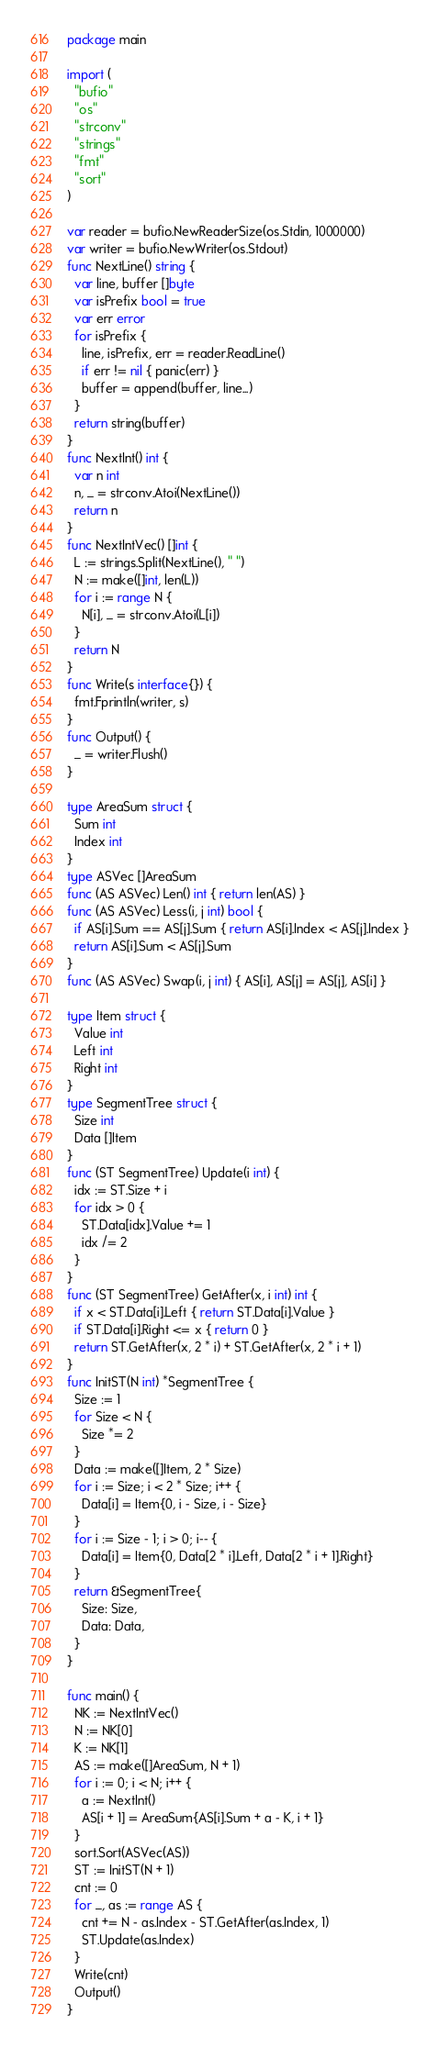<code> <loc_0><loc_0><loc_500><loc_500><_Go_>package main
 
import (
  "bufio"
  "os"
  "strconv"
  "strings"
  "fmt"
  "sort"
)
 
var reader = bufio.NewReaderSize(os.Stdin, 1000000)
var writer = bufio.NewWriter(os.Stdout)
func NextLine() string {
  var line, buffer []byte
  var isPrefix bool = true
  var err error
  for isPrefix {
    line, isPrefix, err = reader.ReadLine()
    if err != nil { panic(err) }
    buffer = append(buffer, line...)
  }
  return string(buffer)
}
func NextInt() int {
  var n int
  n, _ = strconv.Atoi(NextLine())
  return n
}
func NextIntVec() []int {
  L := strings.Split(NextLine(), " ")
  N := make([]int, len(L))
  for i := range N {
    N[i], _ = strconv.Atoi(L[i])
  }
  return N
}
func Write(s interface{}) {
  fmt.Fprintln(writer, s)
}
func Output() {
  _ = writer.Flush()
}

type AreaSum struct {
  Sum int
  Index int
}
type ASVec []AreaSum
func (AS ASVec) Len() int { return len(AS) }
func (AS ASVec) Less(i, j int) bool {
  if AS[i].Sum == AS[j].Sum { return AS[i].Index < AS[j].Index }
  return AS[i].Sum < AS[j].Sum
}
func (AS ASVec) Swap(i, j int) { AS[i], AS[j] = AS[j], AS[i] }

type Item struct {
  Value int
  Left int
  Right int
}
type SegmentTree struct {
  Size int
  Data []Item
}
func (ST SegmentTree) Update(i int) {
  idx := ST.Size + i
  for idx > 0 {
    ST.Data[idx].Value += 1
    idx /= 2
  }
}
func (ST SegmentTree) GetAfter(x, i int) int {
  if x < ST.Data[i].Left { return ST.Data[i].Value }
  if ST.Data[i].Right <= x { return 0 }
  return ST.GetAfter(x, 2 * i) + ST.GetAfter(x, 2 * i + 1)
}
func InitST(N int) *SegmentTree {
  Size := 1
  for Size < N {
    Size *= 2
  }
  Data := make([]Item, 2 * Size)
  for i := Size; i < 2 * Size; i++ {
    Data[i] = Item{0, i - Size, i - Size}
  }
  for i := Size - 1; i > 0; i-- {
    Data[i] = Item{0, Data[2 * i].Left, Data[2 * i + 1].Right}
  }
  return &SegmentTree{
    Size: Size,
    Data: Data,
  }
}

func main() {
  NK := NextIntVec()
  N := NK[0]
  K := NK[1]
  AS := make([]AreaSum, N + 1)
  for i := 0; i < N; i++ {
    a := NextInt()
    AS[i + 1] = AreaSum{AS[i].Sum + a - K, i + 1}
  }
  sort.Sort(ASVec(AS))
  ST := InitST(N + 1)
  cnt := 0
  for _, as := range AS {
    cnt += N - as.Index - ST.GetAfter(as.Index, 1)
    ST.Update(as.Index)
  }
  Write(cnt)
  Output()
}</code> 